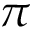Convert formula to latex. <formula><loc_0><loc_0><loc_500><loc_500>\pi</formula> 